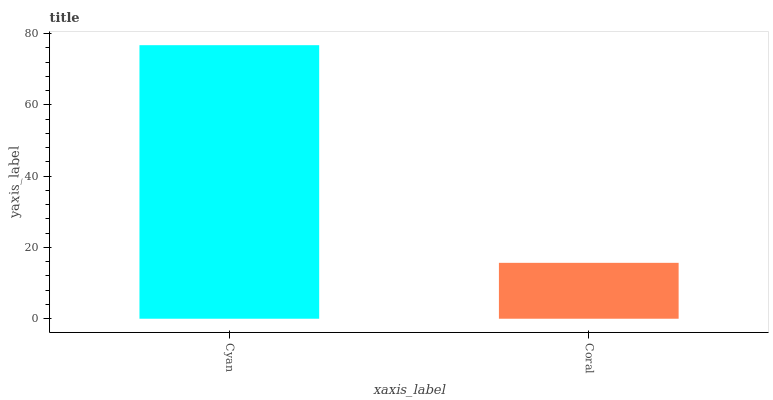Is Coral the maximum?
Answer yes or no. No. Is Cyan greater than Coral?
Answer yes or no. Yes. Is Coral less than Cyan?
Answer yes or no. Yes. Is Coral greater than Cyan?
Answer yes or no. No. Is Cyan less than Coral?
Answer yes or no. No. Is Cyan the high median?
Answer yes or no. Yes. Is Coral the low median?
Answer yes or no. Yes. Is Coral the high median?
Answer yes or no. No. Is Cyan the low median?
Answer yes or no. No. 